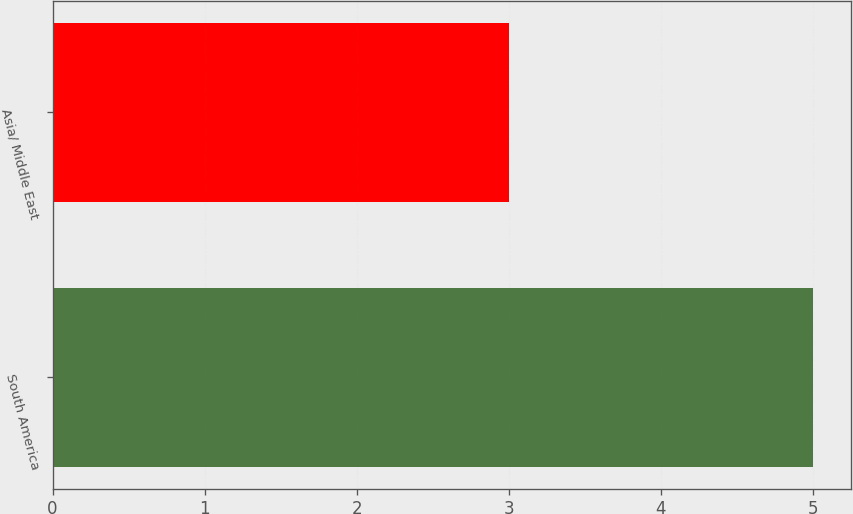Convert chart. <chart><loc_0><loc_0><loc_500><loc_500><bar_chart><fcel>South America<fcel>Asia/ Middle East<nl><fcel>5<fcel>3<nl></chart> 